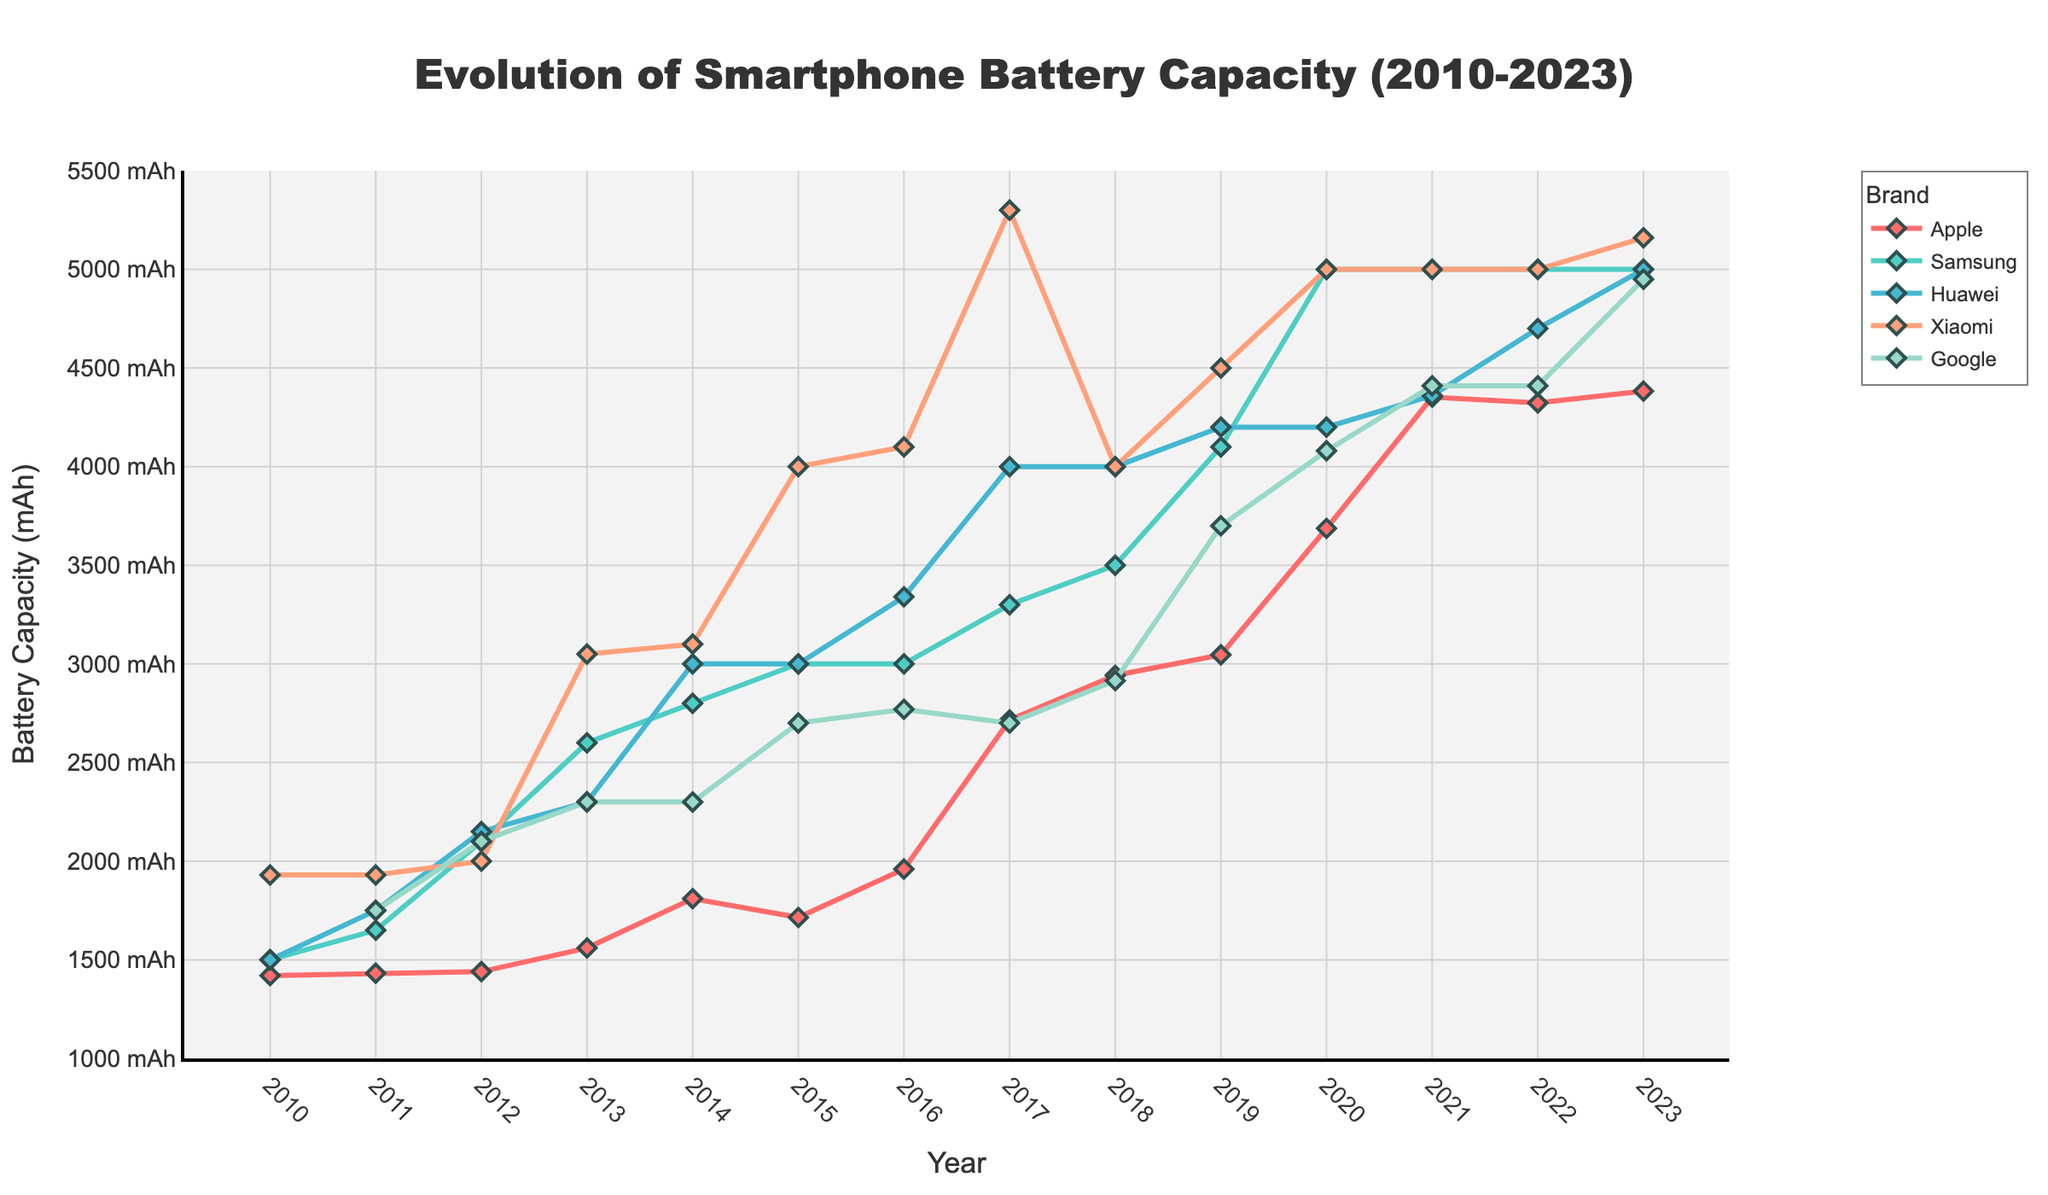Which brand had the largest increase in battery capacity between 2010 and 2023? To determine the largest increase, subtract the 2010 battery capacity from the 2023 battery capacity for each brand. Compare the differences.
Answer: Xiaomi What is the average battery capacity of Huawei smartphones from 2010 to 2023? Sum the battery capacities of Huawei smartphones for each year and then divide by the number of years. ((1500 + 1750 + 2150 + 2300 + 3000 + 3000 + 3340 + 4000 + 4000 + 4200 + 4200 + 4360 + 4700 + 5000) / 14) = 3375
Answer: 3375 mAh How does the battery capacity of Apple in 2023 compare to Google's in 2023? Look at the battery capacities for both brands in 2023 and compare the two values. Apple has 4383 mAh while Google has 4950 mAh, so Google's battery capacity is higher.
Answer: Google's battery capacity is higher Which years did Apple smartphones have a battery capacity increase compared to the previous year? Analyze the Apple battery capacity values year by year and check whether each year’s value is greater than the previous year’s value. Years: 2013 (1560 > 1440), 2017 (2716 > 1960), 2018 (2942 > 2716), 2019 (3046 > 2942), 2020 (3687 > 3046), 2021 (4352 > 3687), 2023 (4383 > 4323)
Answer: 2013, 2017, 2018, 2019, 2020, 2021, 2023 Which brand had the most consistent battery capacity from 2010 to 2023? Compare the fluctuations in battery capacity across the years for each brand. Samsung's battery capacity remained the most consistent in the later years (from 2016 to 2023 it varied only between 3000 and 5000 mAh).
Answer: Samsung What is the median battery capacity for Apple smartphones from 2010 to 2023? Organize Apple battery capacities in ascending order and identify the middle value(s). For even years, average the two middle values. Ordered: 1420, 1432, 1440, 1560, 1715, 1810, 1960, 2716, 2942, 3046, 3687, 4323, 4352, 4383. The median is the average of the 7th and 8th values (1960 + 2716) / 2.
Answer: 2338 mAh Which brand had the highest peak battery capacity and in which year? Review the maximum battery capacity values for all brands and identify the highest value and corresponding year. Xiaomi had the highest peak with 5300 mAh in 2017.
Answer: Xiaomi in 2017 When did Google's battery capacity first reach 4000 mAh? Check the Google battery capacity data year by year until the value reaches 4000 mAh. It first reached 4000 mAh in 2020.
Answer: 2020 By how much did Xiaomi's battery capacity increase from 2013 to 2015? Subtract Xiaomi's 2013 battery capacity from its 2015 battery capacity. (4000 - 3050).
Answer: 950 mAh Which brand experienced a drop in battery capacity anytime between 2010 and 2023? Check each brand's data for any year-over-year decrease. Apple had drops between 2014-2015 (1810 to 1715), Huawei drops can be noticed between 2021 and 2022 (from 4360 to 4700).
Answer: Apple, Huawei What is the combined battery increase for Samsung and Huawei from 2011 to 2013? For both brands, subtract 2011 battery capacities from 2013 values and sum the differences. Samsung: (2600 - 1650), Huawei: (2300 - 1750). (950 + 550).
Answer: 1500 mAh 